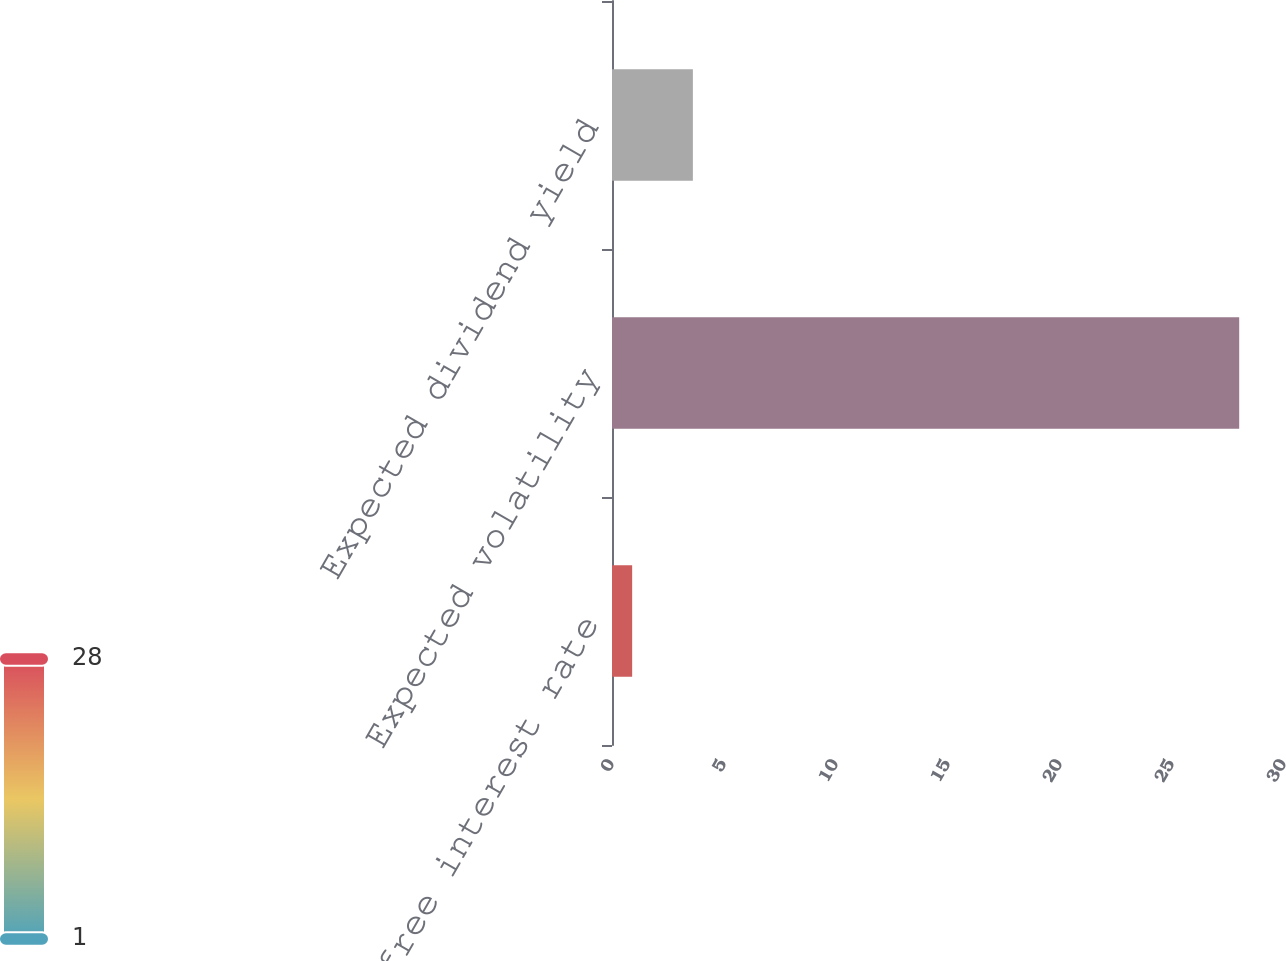Convert chart. <chart><loc_0><loc_0><loc_500><loc_500><bar_chart><fcel>Risk free interest rate<fcel>Expected volatility<fcel>Expected dividend yield<nl><fcel>0.9<fcel>28<fcel>3.61<nl></chart> 